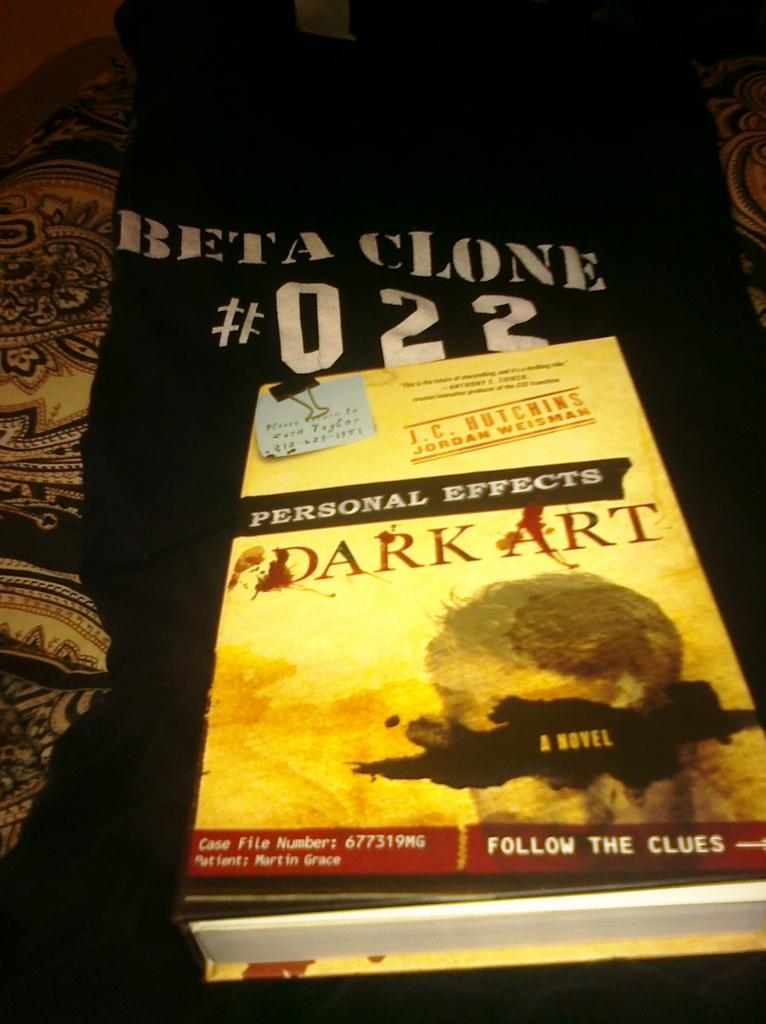Provide a one-sentence caption for the provided image. A book titled Dark Art sits on a black shirt. 